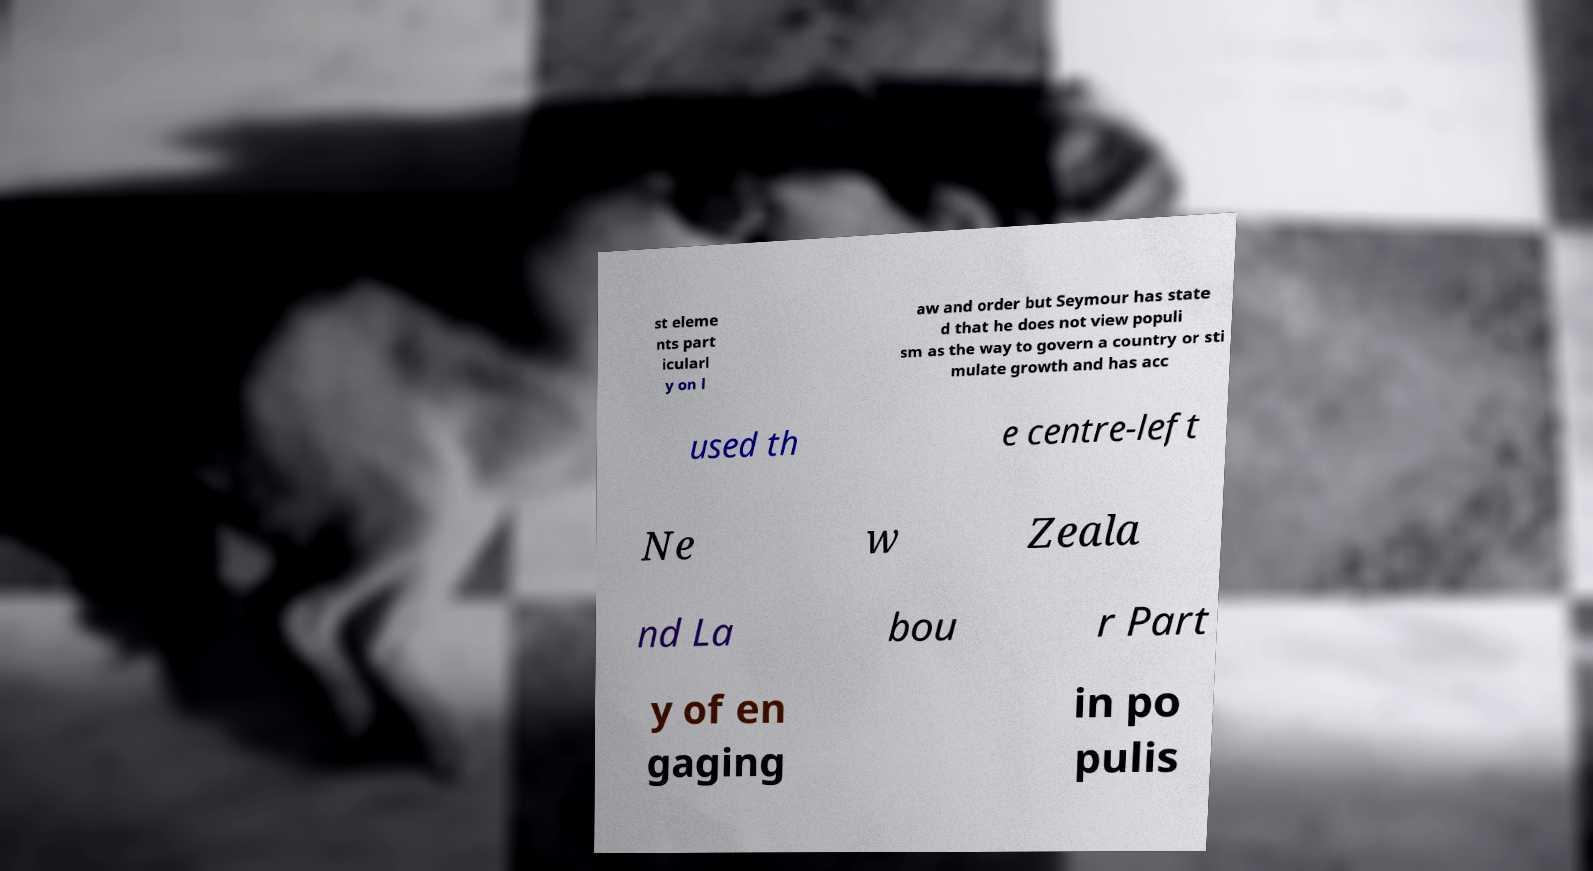There's text embedded in this image that I need extracted. Can you transcribe it verbatim? st eleme nts part icularl y on l aw and order but Seymour has state d that he does not view populi sm as the way to govern a country or sti mulate growth and has acc used th e centre-left Ne w Zeala nd La bou r Part y of en gaging in po pulis 